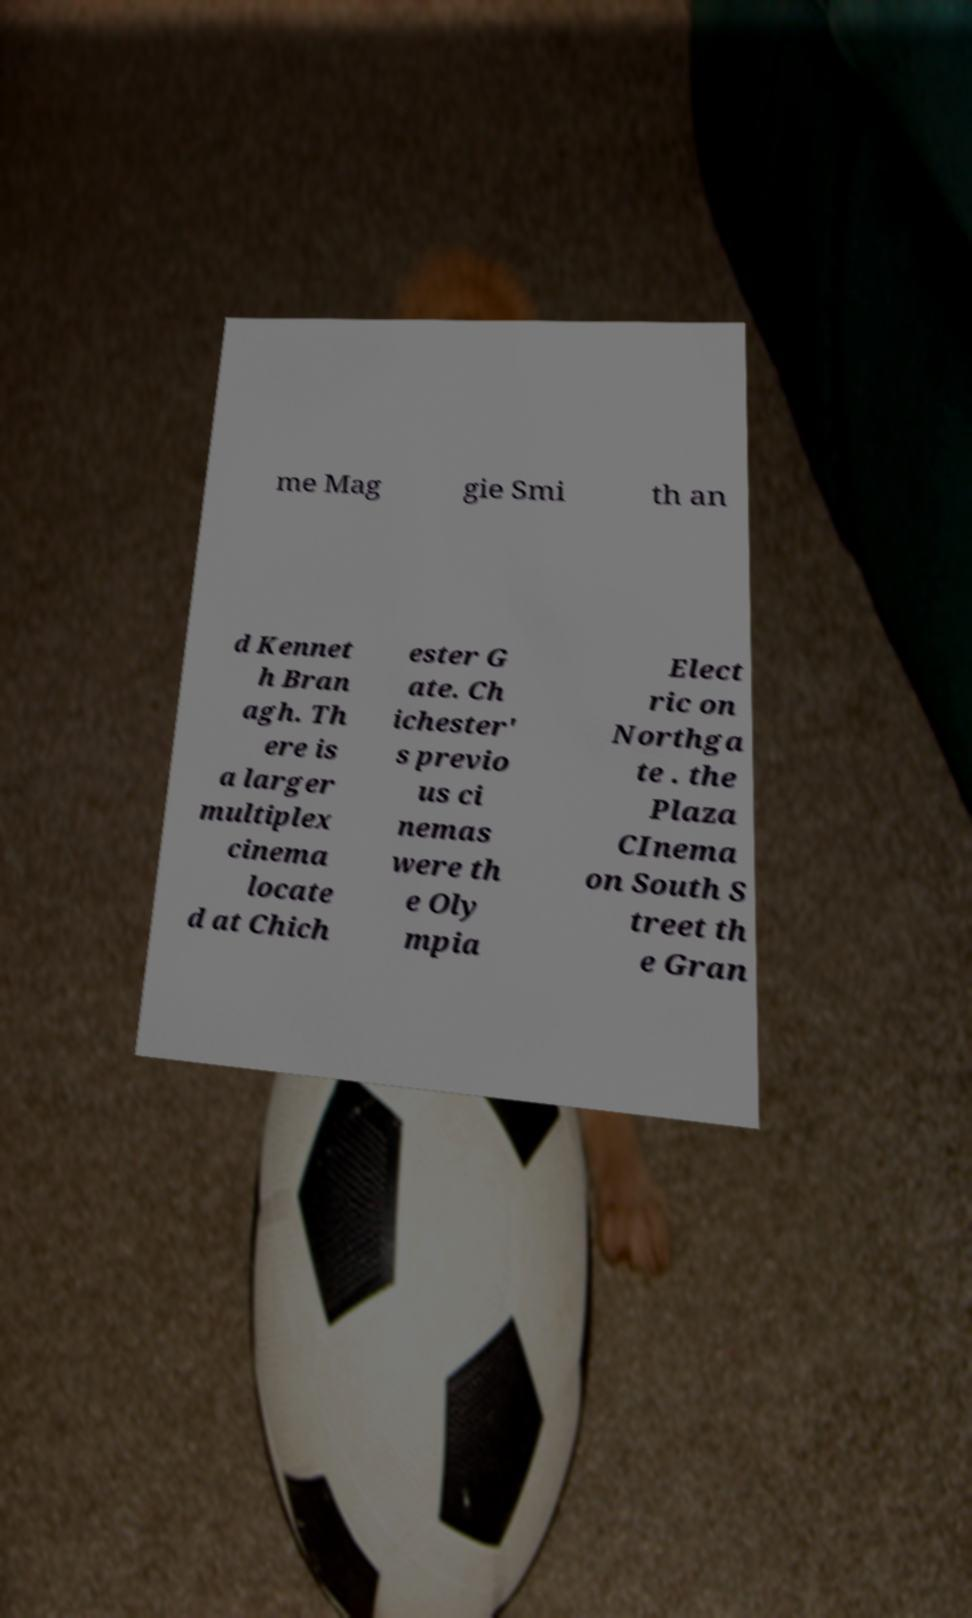Please read and relay the text visible in this image. What does it say? me Mag gie Smi th an d Kennet h Bran agh. Th ere is a larger multiplex cinema locate d at Chich ester G ate. Ch ichester' s previo us ci nemas were th e Oly mpia Elect ric on Northga te . the Plaza CInema on South S treet th e Gran 